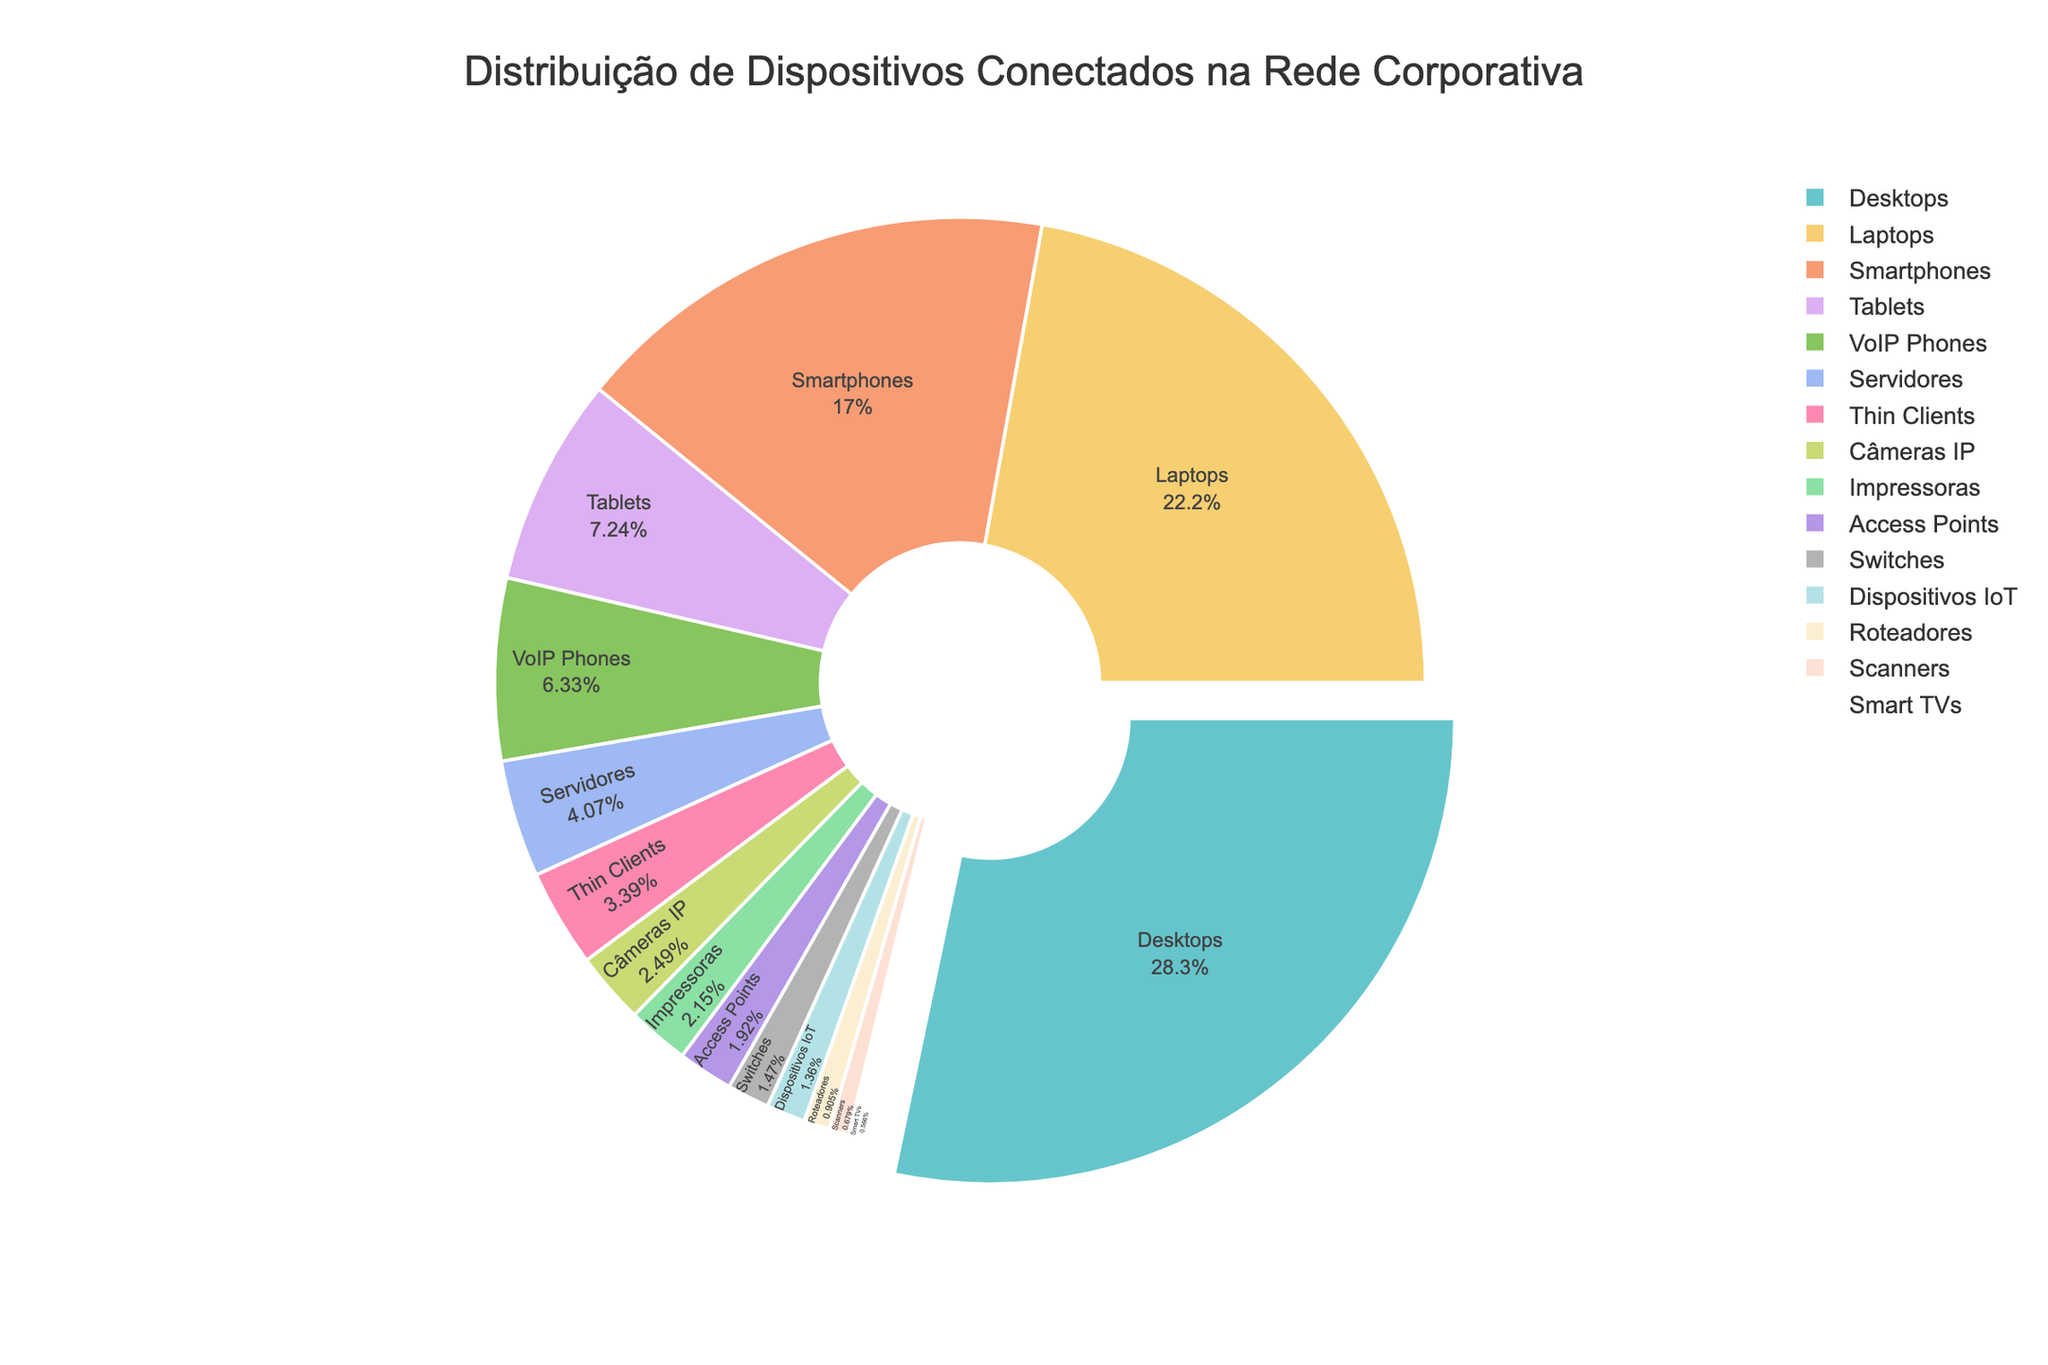Qual é o dispositivo mais representado na rede corporativa? O gráfico de pizza mostra a porcentagem de cada tipo de dispositivo. O maior segmento do gráfico pertence aos Desktops, representando a maior quantidade de dispositivos.
Answer: Desktops Qual tipo de dispositivo tem uma menor representação na rede corporativa do que Smartphones mas maior do que Tablets? Observando os segmentos no gráfico, Tablets têm uma representação menor que Smartphones, mas VoIP Phones têm uma representação maior que Tablets e menor que Smartphones.
Answer: VoIP Phones Quais dispositivos representam conjuntamente menos de 10% da rede? Analisando os segmentos menores no gráfico, do total, dispositivos como Roteadores, Scanners, Smart TVs e Dispositivos IoT cada um representa menos de 10% da rede. O conjunto desses será muito pequeno visualmente.
Answer: Roteadores, Scanners, Smart TVs, Dispositivos IoT Quantos dispositivos são representados por Tablets e Servidores juntos? A quantidade de Tablets é 320 e a quantidade de Servidores é 180. Somando essas duas quantidades resultamos em 320 + 180.
Answer: 500 Qual é a proporção dos dispositivos móveis (Smartphones e Tablets) em comparação com dispositivos fixos (Desktops e Servidores)? Primeiro, calcula-se o total de dispositivos móveis: Smartphones (750) + Tablets (320) = 1070. Depois, calcula-se o total de dispositivos fixos: Desktops (1250) + Servidores (180) = 1430. Por fim, comparamos os totais móveis e fixos para encontrar a proporção.
Answer: 1070 : 1430 Qual dispositivo tem uma representação ligeiramente maior do que Access Points? Examinando os segmentos do gráfico, os Thin Clients têm uma quantidade um pouco maior do que Access Points.
Answer: Thin Clients Se você combinasse a quantidade de Impressoras e Câmeras IP, qual seria a proporção em relação ao total de VoIP Phones? A quantidade de Impressoras é 95 e Câmeras IP é 110, juntos somam 205. A quantidade de VoIP Phones é 280. Para encontrar a proporção, divide-se 205 por 280.
Answer: 205 : 280 Quais dispositivos têm quase a mesma quantidade? Observando os segmentos do gráfico, Thin Clients (150) e VoIP Phones (280) são próximos em quantidade relativa, ao ponto de não ter uma marcação visualmente muito diferente.
Answer: VoIP Phones, Access Points Qual é a representação de dispositivos IoT em relação a Smart TVs? A representação de Dispositivos IoT é 60 e de Smart TVs é 25. A proporção entre eles é 60 dividido por 25.
Answer: 60 : 25 Quais dispositivos têm quantidades maiores que 100 mas não superiores a 200? Olhando os segmentos do gráfico, os dispositivos que têm uma quantidade nessa faixa são Câmeras IP (110) e Servidores (180).
Answer: Câmeras IP, Servidores 